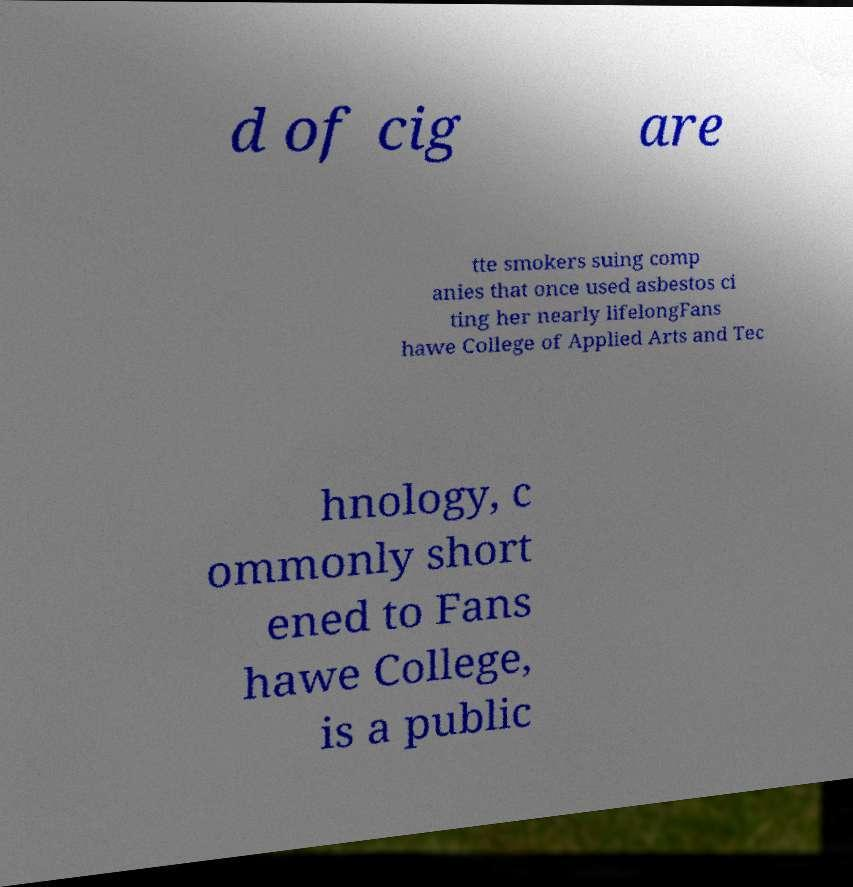Please identify and transcribe the text found in this image. d of cig are tte smokers suing comp anies that once used asbestos ci ting her nearly lifelongFans hawe College of Applied Arts and Tec hnology, c ommonly short ened to Fans hawe College, is a public 